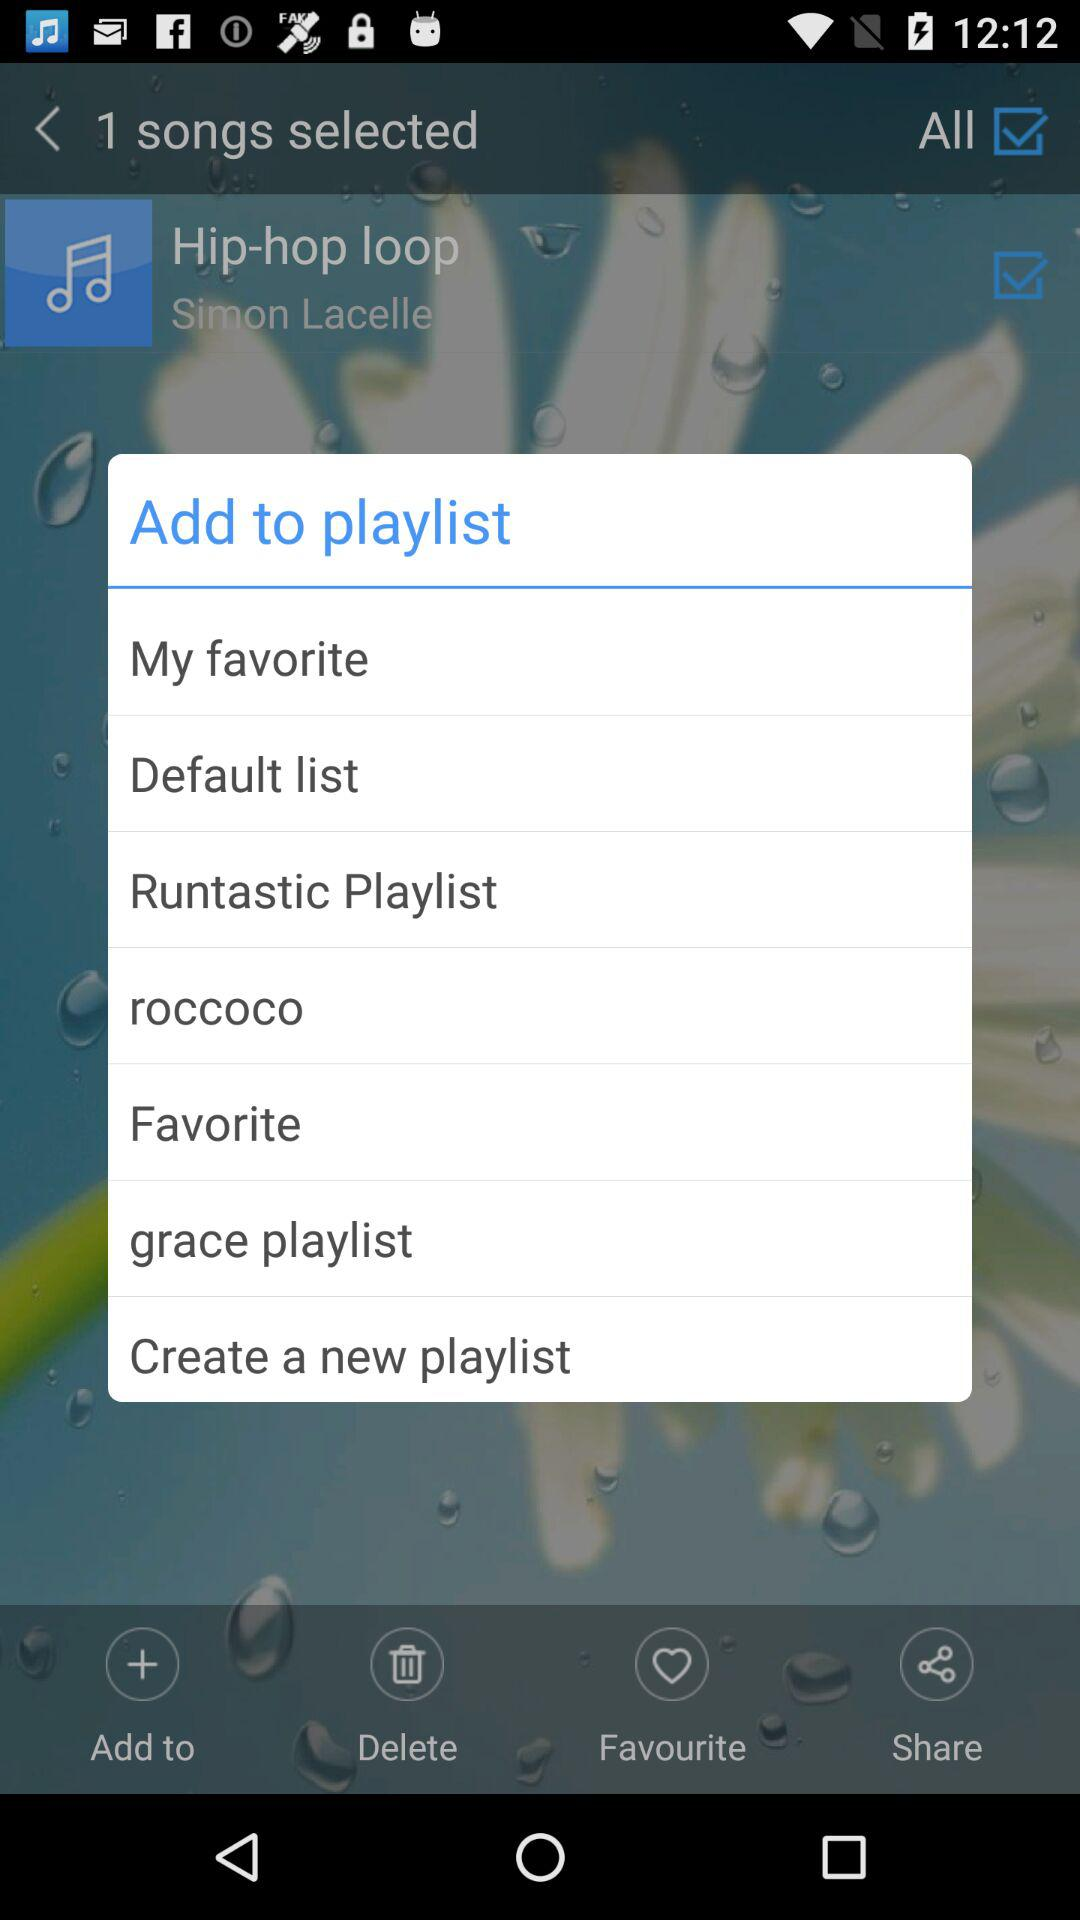Who is the artist? The artist is Simon Lacelle. 